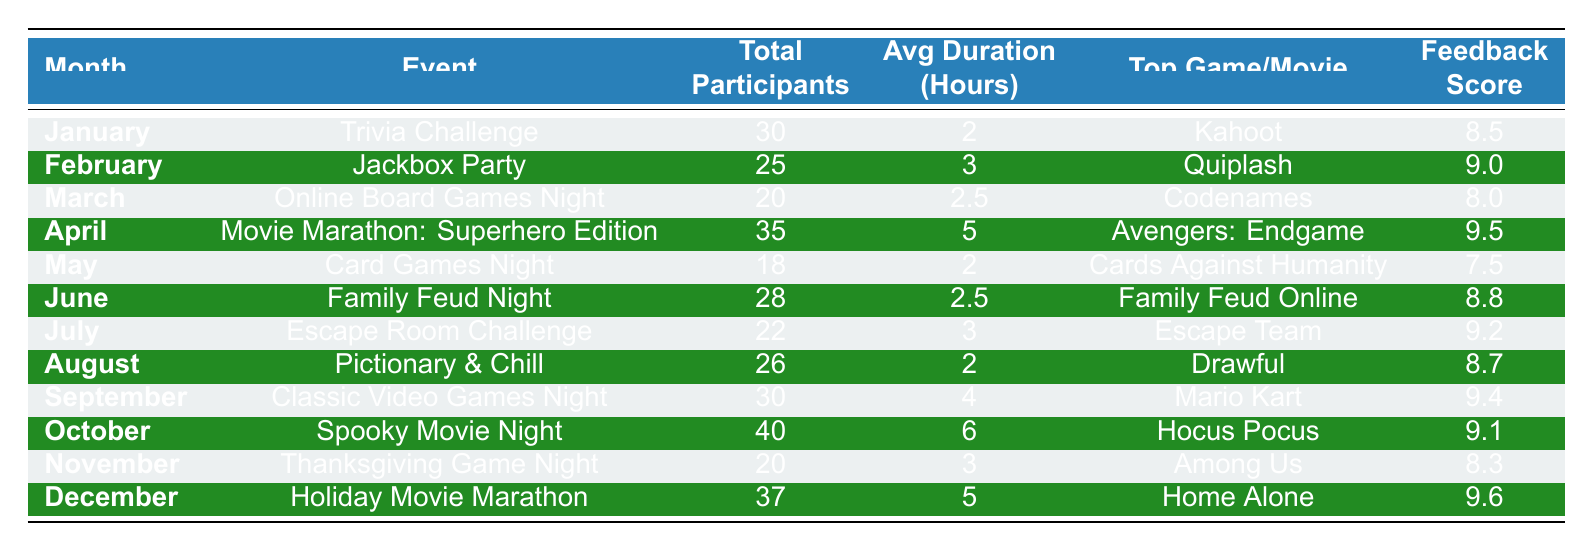What was the top game played in January? In January, the event was Trivia Challenge, and the table indicates that the top game played was Kahoot.
Answer: Kahoot How many participants joined the Escape Room Challenge in July? The table shows that during July, for the Escape Room Challenge, there were 22 participants.
Answer: 22 What is the average feedback score for events held in the first half of the year (January to June)? The feedback scores for the first half of the year are: 8.5 (January) + 9.0 (February) + 8.0 (March) + 9.5 (April) + 7.5 (May) + 8.8 (June) = 51.3. There are 6 events, so the average is 51.3 / 6 = 8.55.
Answer: 8.55 Which month had the highest attendance, and what was the event? The highest attendance was in October, with 40 participants for the Spooky Movie Night event.
Answer: October, Spooky Movie Night How does the average duration of the events in the second half of the year compare to the first half of the year? The average duration for the first half of the year is (2 + 3 + 2.5 + 5 + 2 + 2.5) / 6 = 2.83 hours. For the second half (3 + 2 + 4 + 6 + 3 + 5) / 6 = 4.83 hours. The second half had a longer average duration than the first half.
Answer: Second half is longer Was the average participant feedback score higher for movie marathons compared to game nights? The feedback scores for movie marathons are 9.5 (April) and 9.1 (October), averaging 9.3. The feedback scores for game nights (January 8.5, February 9.0, March 8.0, May 7.5, June 8.8, July 9.2, August 8.7, September 9.4, November 8.3) average to 8.65. Thus, movie marathons did have a higher average score.
Answer: Yes What was the total number of participants across all events in December? The table shows that in December, there were 37 participants for the Holiday Movie Marathon event.
Answer: 37 Which event had the lowest feedback score, and how many participants were there? The event with the lowest feedback score was Card Games Night in May, with a score of 7.5 and 18 participants.
Answer: Card Games Night, 18 participants What is the total number of participants for all game nights throughout the year? Summing the total participants: 30 (Jan) + 25 (Feb) + 20 (Mar) + 18 (May) + 28 (Jun) + 22 (Jul) + 26 (Aug) + 30 (Sep) + 20 (Nov) = 229 participants.
Answer: 229 How many games were played in total during June and July's events? In June, Family Feud Night had one game: Family Feud Online, and in July, the Escape Room Challenge had two games: Escape Team and Exit. Therefore, the total number of games is 1 (June) + 2 (July) = 3.
Answer: 3 Was there an increase in attendance from January to October? January had 30 attendees and October had 40 attendees. Since 40 is greater than 30, it indicates an increase in attendance.
Answer: Yes 